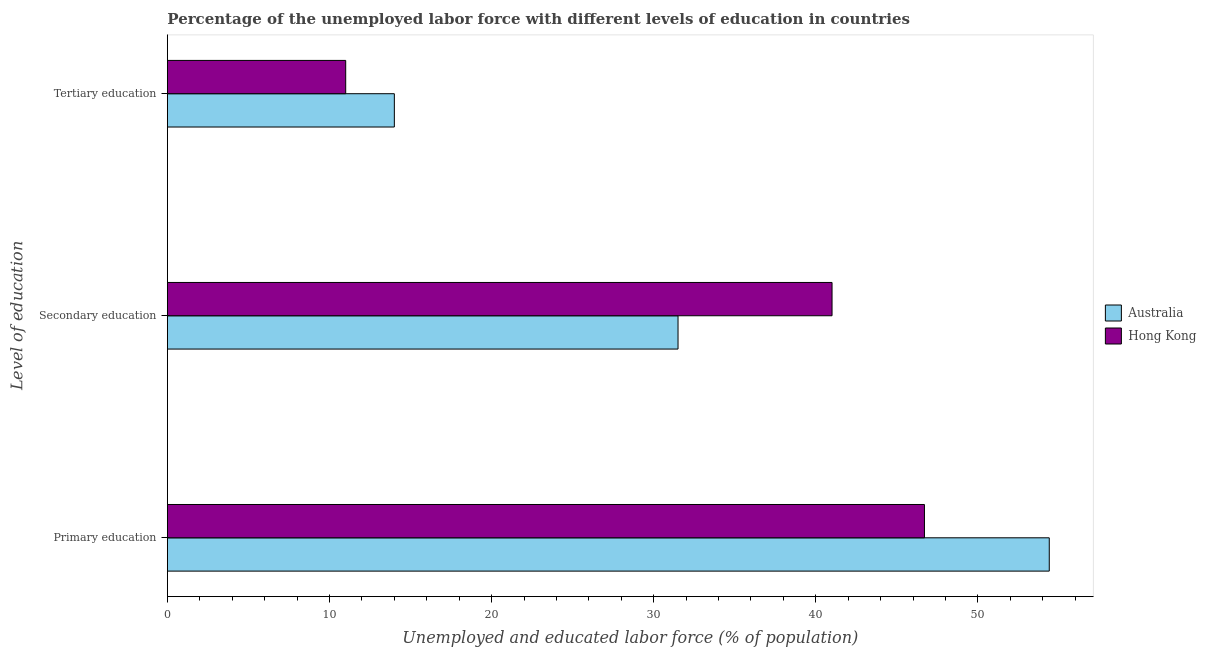How many different coloured bars are there?
Your answer should be very brief. 2. How many groups of bars are there?
Keep it short and to the point. 3. How many bars are there on the 1st tick from the top?
Your answer should be compact. 2. How many bars are there on the 1st tick from the bottom?
Your answer should be compact. 2. What is the label of the 1st group of bars from the top?
Offer a terse response. Tertiary education. Across all countries, what is the maximum percentage of labor force who received secondary education?
Make the answer very short. 41. In which country was the percentage of labor force who received secondary education maximum?
Provide a succinct answer. Hong Kong. In which country was the percentage of labor force who received primary education minimum?
Offer a very short reply. Hong Kong. What is the total percentage of labor force who received primary education in the graph?
Provide a succinct answer. 101.1. What is the difference between the percentage of labor force who received tertiary education in Australia and the percentage of labor force who received secondary education in Hong Kong?
Give a very brief answer. -27. What is the average percentage of labor force who received primary education per country?
Give a very brief answer. 50.55. In how many countries, is the percentage of labor force who received secondary education greater than 2 %?
Keep it short and to the point. 2. What is the ratio of the percentage of labor force who received primary education in Australia to that in Hong Kong?
Make the answer very short. 1.16. Is the percentage of labor force who received primary education in Australia less than that in Hong Kong?
Provide a succinct answer. No. Is the difference between the percentage of labor force who received tertiary education in Australia and Hong Kong greater than the difference between the percentage of labor force who received secondary education in Australia and Hong Kong?
Provide a succinct answer. Yes. What is the difference between the highest and the second highest percentage of labor force who received primary education?
Your response must be concise. 7.7. What is the difference between the highest and the lowest percentage of labor force who received tertiary education?
Your answer should be very brief. 3. Is the sum of the percentage of labor force who received primary education in Hong Kong and Australia greater than the maximum percentage of labor force who received tertiary education across all countries?
Ensure brevity in your answer.  Yes. How many bars are there?
Keep it short and to the point. 6. How many countries are there in the graph?
Offer a very short reply. 2. What is the difference between two consecutive major ticks on the X-axis?
Make the answer very short. 10. Does the graph contain any zero values?
Offer a very short reply. No. Does the graph contain grids?
Keep it short and to the point. No. How many legend labels are there?
Offer a terse response. 2. What is the title of the graph?
Offer a terse response. Percentage of the unemployed labor force with different levels of education in countries. Does "India" appear as one of the legend labels in the graph?
Your response must be concise. No. What is the label or title of the X-axis?
Your answer should be compact. Unemployed and educated labor force (% of population). What is the label or title of the Y-axis?
Offer a terse response. Level of education. What is the Unemployed and educated labor force (% of population) of Australia in Primary education?
Provide a succinct answer. 54.4. What is the Unemployed and educated labor force (% of population) of Hong Kong in Primary education?
Offer a very short reply. 46.7. What is the Unemployed and educated labor force (% of population) in Australia in Secondary education?
Your answer should be very brief. 31.5. What is the Unemployed and educated labor force (% of population) of Hong Kong in Tertiary education?
Offer a very short reply. 11. Across all Level of education, what is the maximum Unemployed and educated labor force (% of population) of Australia?
Your answer should be compact. 54.4. Across all Level of education, what is the maximum Unemployed and educated labor force (% of population) of Hong Kong?
Provide a short and direct response. 46.7. What is the total Unemployed and educated labor force (% of population) in Australia in the graph?
Give a very brief answer. 99.9. What is the total Unemployed and educated labor force (% of population) in Hong Kong in the graph?
Ensure brevity in your answer.  98.7. What is the difference between the Unemployed and educated labor force (% of population) in Australia in Primary education and that in Secondary education?
Keep it short and to the point. 22.9. What is the difference between the Unemployed and educated labor force (% of population) in Australia in Primary education and that in Tertiary education?
Your answer should be compact. 40.4. What is the difference between the Unemployed and educated labor force (% of population) of Hong Kong in Primary education and that in Tertiary education?
Your answer should be very brief. 35.7. What is the difference between the Unemployed and educated labor force (% of population) in Australia in Secondary education and that in Tertiary education?
Your answer should be compact. 17.5. What is the difference between the Unemployed and educated labor force (% of population) in Australia in Primary education and the Unemployed and educated labor force (% of population) in Hong Kong in Tertiary education?
Provide a short and direct response. 43.4. What is the average Unemployed and educated labor force (% of population) in Australia per Level of education?
Provide a short and direct response. 33.3. What is the average Unemployed and educated labor force (% of population) of Hong Kong per Level of education?
Your answer should be very brief. 32.9. What is the difference between the Unemployed and educated labor force (% of population) in Australia and Unemployed and educated labor force (% of population) in Hong Kong in Secondary education?
Your answer should be compact. -9.5. What is the ratio of the Unemployed and educated labor force (% of population) of Australia in Primary education to that in Secondary education?
Offer a very short reply. 1.73. What is the ratio of the Unemployed and educated labor force (% of population) in Hong Kong in Primary education to that in Secondary education?
Keep it short and to the point. 1.14. What is the ratio of the Unemployed and educated labor force (% of population) of Australia in Primary education to that in Tertiary education?
Provide a short and direct response. 3.89. What is the ratio of the Unemployed and educated labor force (% of population) of Hong Kong in Primary education to that in Tertiary education?
Offer a very short reply. 4.25. What is the ratio of the Unemployed and educated labor force (% of population) of Australia in Secondary education to that in Tertiary education?
Your answer should be compact. 2.25. What is the ratio of the Unemployed and educated labor force (% of population) of Hong Kong in Secondary education to that in Tertiary education?
Keep it short and to the point. 3.73. What is the difference between the highest and the second highest Unemployed and educated labor force (% of population) in Australia?
Your answer should be very brief. 22.9. What is the difference between the highest and the lowest Unemployed and educated labor force (% of population) of Australia?
Offer a terse response. 40.4. What is the difference between the highest and the lowest Unemployed and educated labor force (% of population) of Hong Kong?
Give a very brief answer. 35.7. 